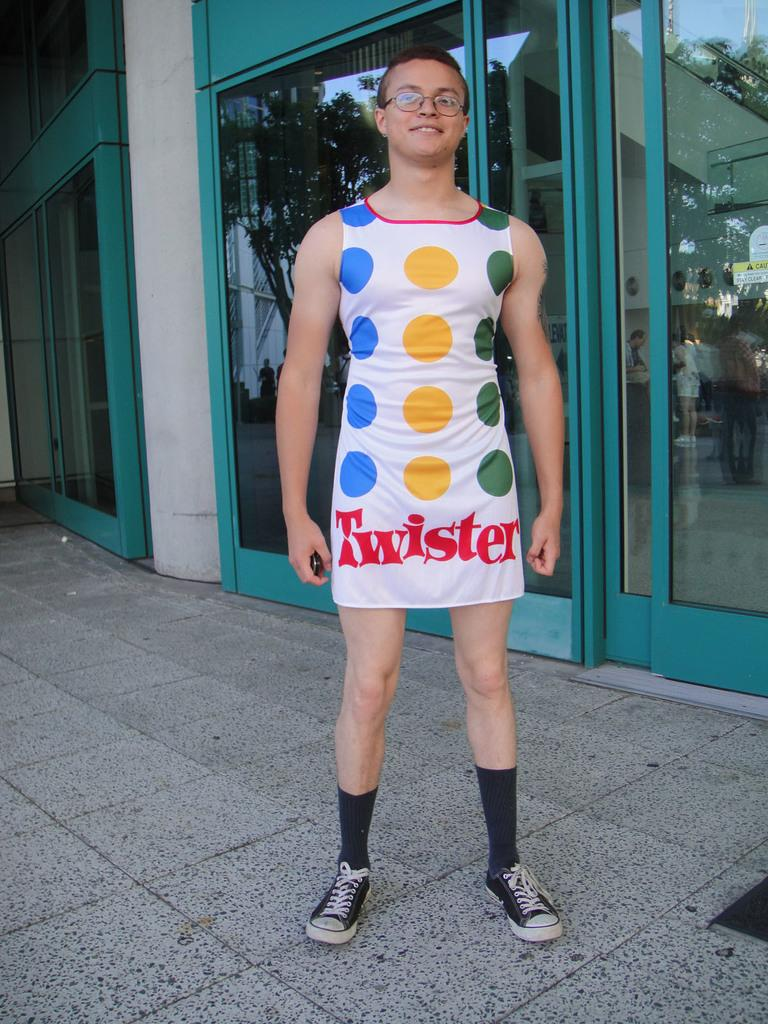<image>
Give a short and clear explanation of the subsequent image. The male shown is wearing a twister fancy dress costume. 